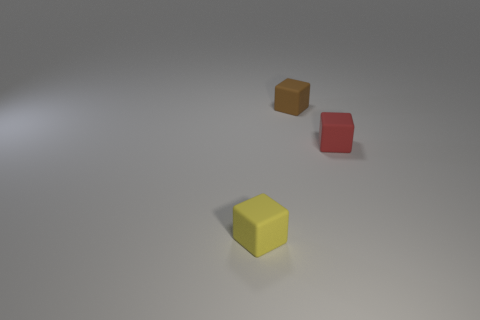How many things are tiny purple metal balls or objects that are in front of the tiny brown object?
Provide a succinct answer. 2. There is a tiny yellow thing that is the same shape as the small brown matte object; what is its material?
Ensure brevity in your answer.  Rubber. Is there anything else that has the same material as the tiny yellow thing?
Make the answer very short. Yes. What material is the thing that is behind the small yellow rubber object and on the left side of the tiny red cube?
Give a very brief answer. Rubber. What number of red rubber objects are the same shape as the tiny yellow thing?
Your answer should be very brief. 1. There is a matte block behind the small object that is right of the small brown matte cube; what color is it?
Your response must be concise. Brown. Is the number of small yellow rubber blocks that are behind the yellow rubber thing the same as the number of red rubber objects?
Your response must be concise. No. Are there any other rubber cubes of the same size as the yellow cube?
Keep it short and to the point. Yes. There is a red matte object; is its size the same as the cube behind the small red cube?
Give a very brief answer. Yes. Is the number of yellow cubes that are right of the tiny yellow thing the same as the number of brown objects that are on the left side of the small brown matte cube?
Provide a short and direct response. Yes. 